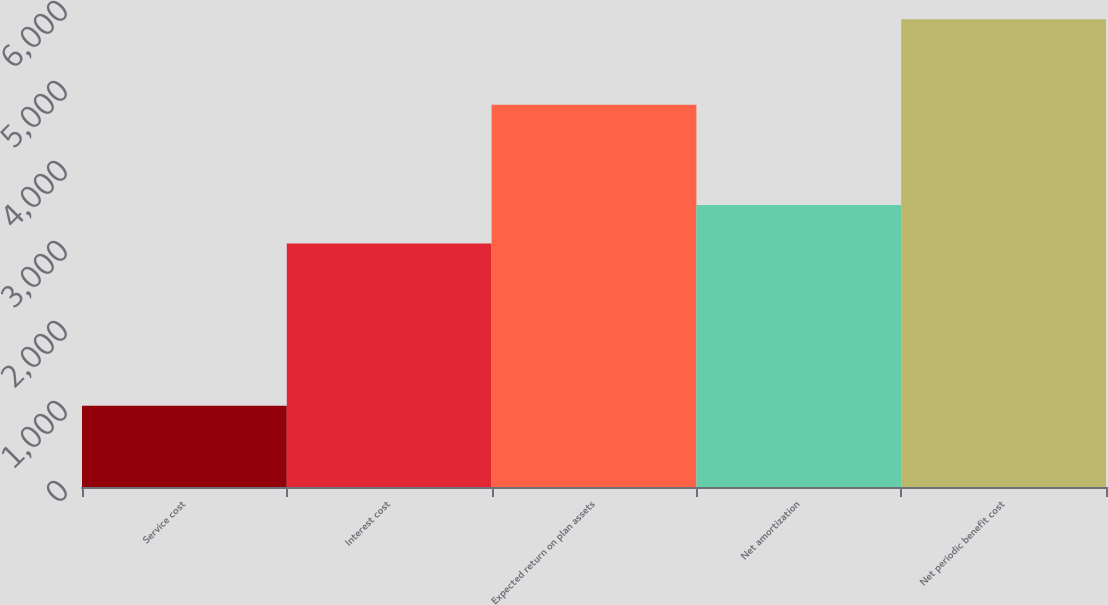Convert chart to OTSL. <chart><loc_0><loc_0><loc_500><loc_500><bar_chart><fcel>Service cost<fcel>Interest cost<fcel>Expected return on plan assets<fcel>Net amortization<fcel>Net periodic benefit cost<nl><fcel>1016<fcel>3043<fcel>4777<fcel>3526.1<fcel>5847<nl></chart> 